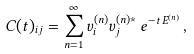<formula> <loc_0><loc_0><loc_500><loc_500>C ( t ) _ { i j } = \sum _ { n = 1 } ^ { \infty } v _ { i } ^ { ( n ) } v _ { j } ^ { ( n ) * } \, e ^ { - t \, E ^ { ( n ) } } \, ,</formula> 